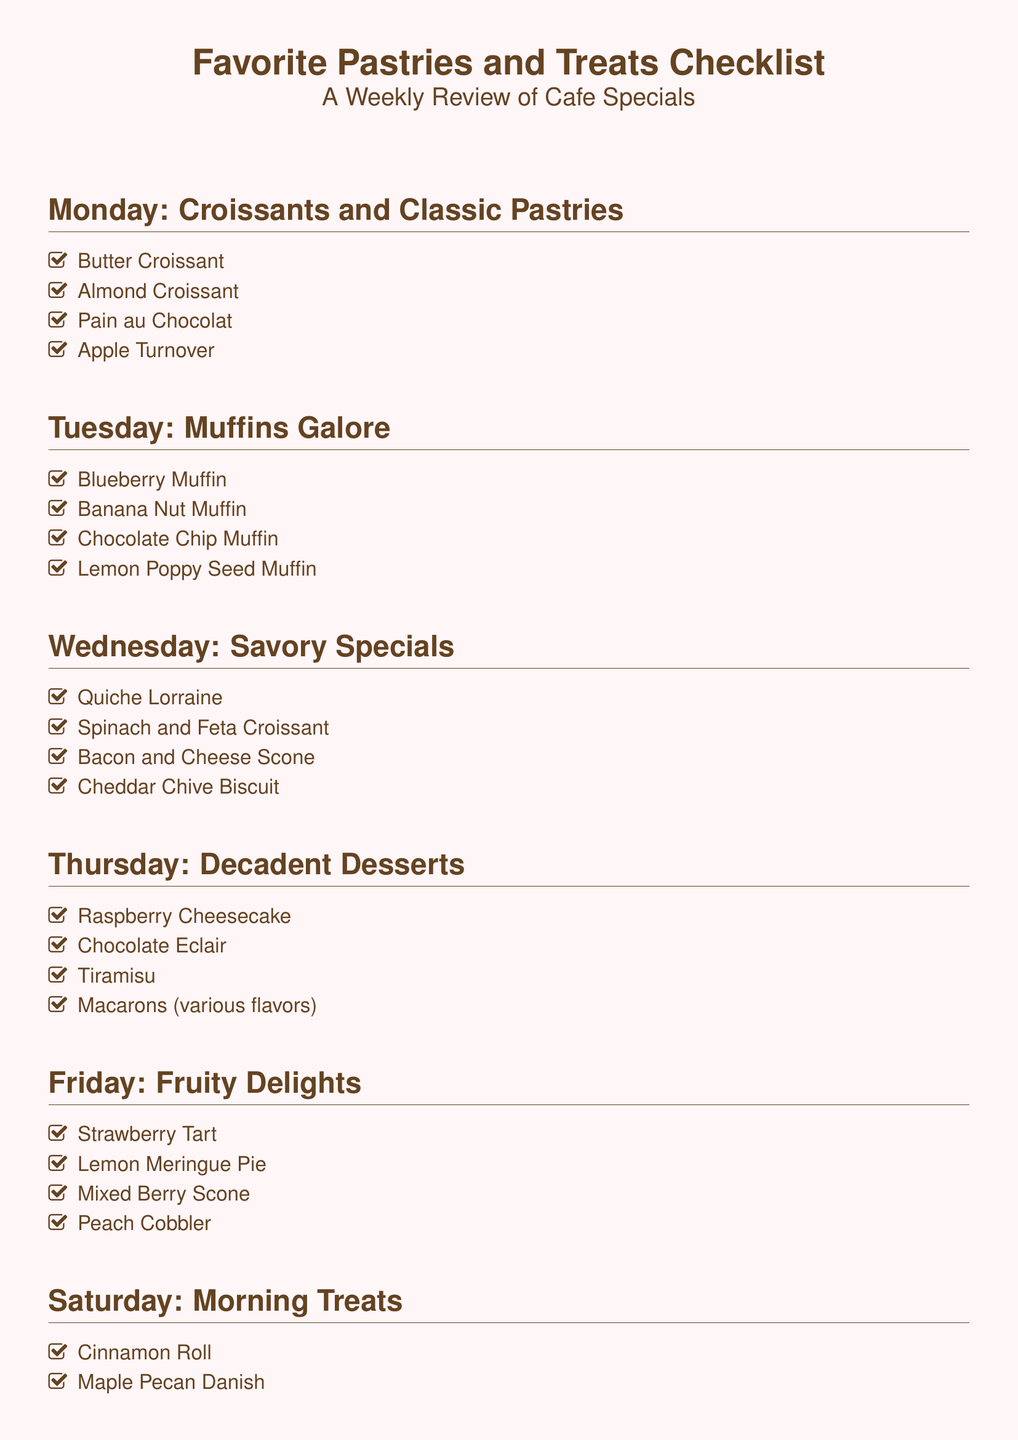What pastries are featured on Monday? The Monday section lists the pastries that are available, specifically Butter Croissant, Almond Croissant, Pain au Chocolat, and Apple Turnover.
Answer: Butter Croissant, Almond Croissant, Pain au Chocolat, Apple Turnover Which day features muffins? The Tuesday section is specifically dedicated to muffins, highlighting that day for their special offer.
Answer: Tuesday How many pastries are listed for Sunday? To find the answer, we count the number of items listed under the Sunday section, which are four distinct treats.
Answer: Four What is the pastry of the week on Thursday? The Thursday section presents decadent desserts, notably featuring Raspberry Cheesecake as the first item in the list.
Answer: Raspberry Cheesecake Which pastry would be a savory treat? The Wednesday section includes items that are defined as savory, notably mentioning Quiche Lorraine as the first entry.
Answer: Quiche Lorraine What type of cake is featured on Saturday? Among the pastries listed for Saturday, there is a Coffee Cake included in the menu for that day.
Answer: Coffee Cake How many different types of muffins are available on Tuesday? By counting the items in the Tuesday section, we find there are four different varieties of muffins listed.
Answer: Four What dessert is described as the Chef's Special on Sunday? The section on Sunday includes various special items, with Chocolate Lava Cake being mentioned in the list.
Answer: Chocolate Lava Cake 